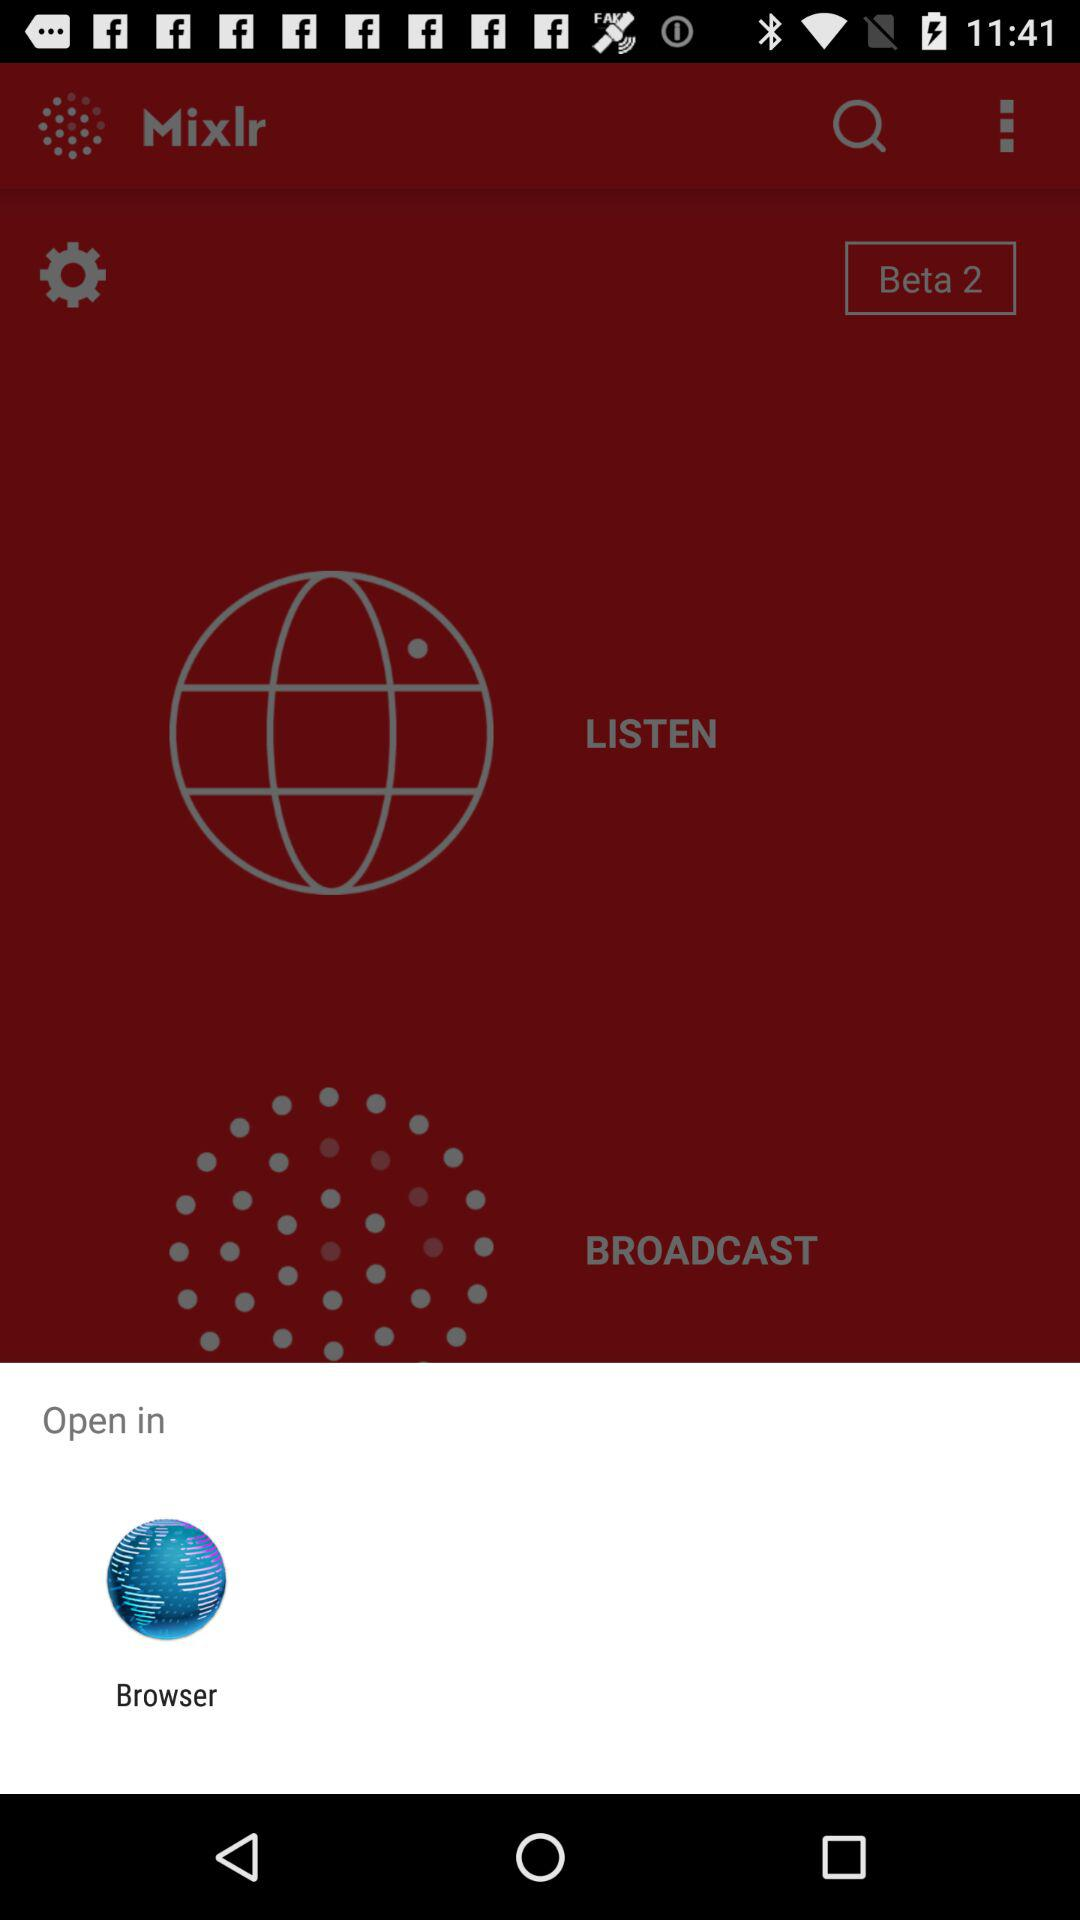Through what application can we open it? You can open it through "Browser". 